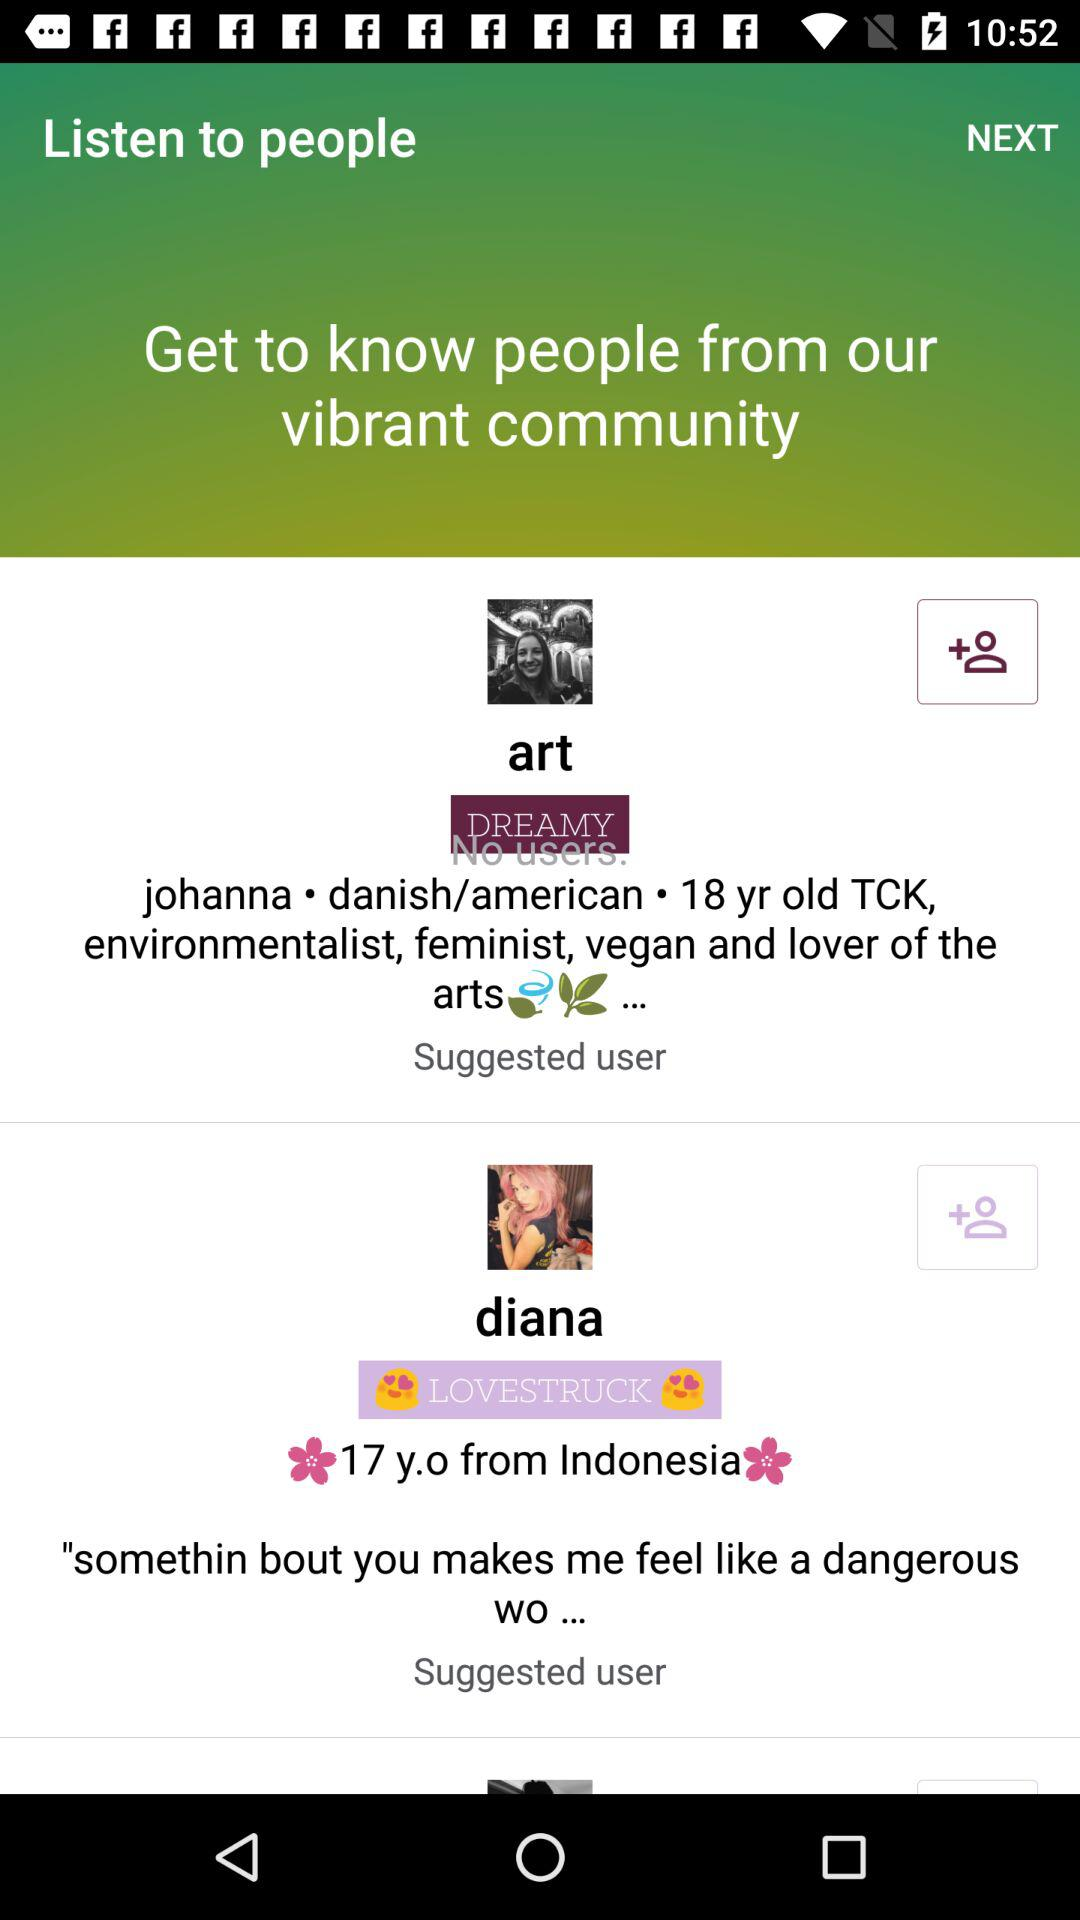Which country does Diana live in? Diana lives in Indonesia. 